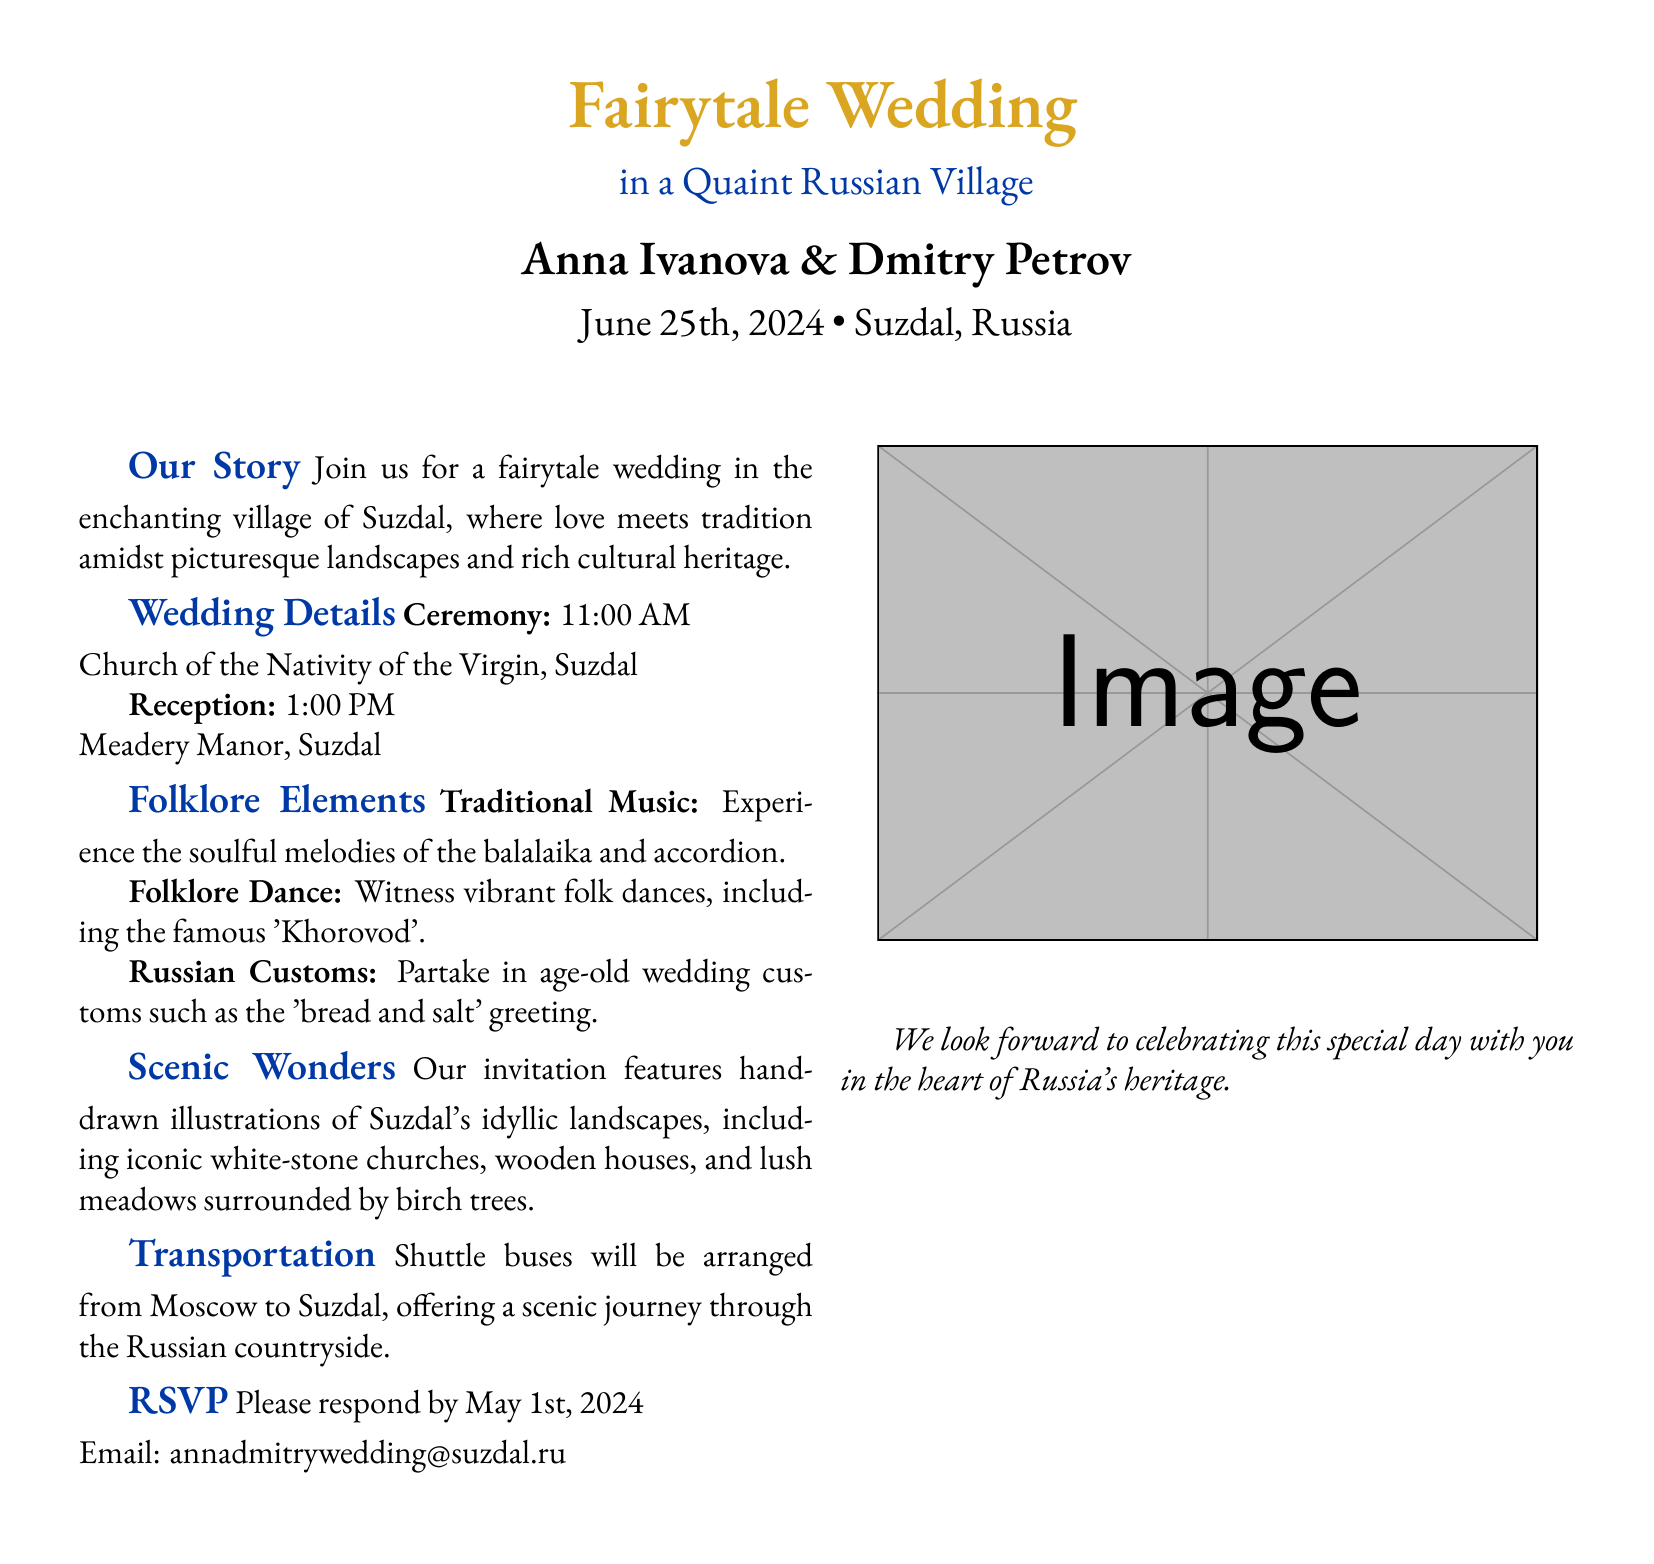What is the name of the bride? The document states the name of the bride as Anna Ivanova.
Answer: Anna Ivanova What is the wedding date? The wedding date is specified in the document as June 25th, 2024.
Answer: June 25th, 2024 Where is the ceremony taking place? The document indicates that the ceremony will be held at the Church of the Nativity of the Virgin in Suzdal.
Answer: Church of the Nativity of the Virgin, Suzdal What traditional dance will be featured? The document mentions the vibrant folk dance known as 'Khorovod' will be part of the festivities.
Answer: Khorovod What time does the reception start? The reception time is listed in the document as 1:00 PM.
Answer: 1:00 PM What color is associated with the wedding invitation? The document includes color information describing 'russiangold' as RGB(218,165,32).
Answer: russiangold What type of music will be played at the wedding? The document mentions the traditional music featuring the balalaika and accordion.
Answer: balalaika and accordion What is the RSVP deadline? The RSVP deadline is explicitly stated in the document as May 1st, 2024.
Answer: May 1st, 2024 How will guests travel from Moscow to Suzdal? The invitation mentions shuttle buses will be arranged for transportation from Moscow to Suzdal.
Answer: Shuttle buses 